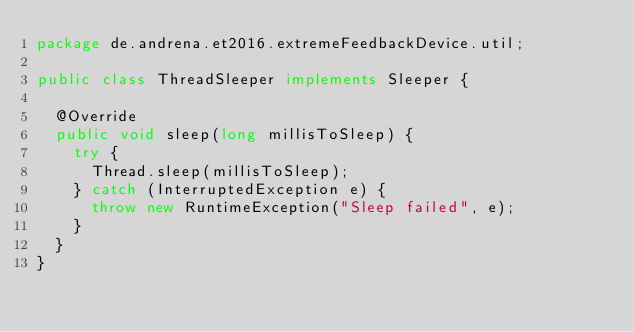<code> <loc_0><loc_0><loc_500><loc_500><_Java_>package de.andrena.et2016.extremeFeedbackDevice.util;

public class ThreadSleeper implements Sleeper {

	@Override
	public void sleep(long millisToSleep) {
		try {
			Thread.sleep(millisToSleep);
		} catch (InterruptedException e) {
			throw new RuntimeException("Sleep failed", e);
		}
	}
}
</code> 